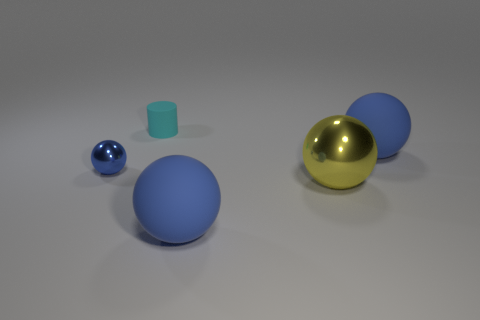How many blue balls must be subtracted to get 1 blue balls? 2 Subtract all brown cubes. How many blue balls are left? 3 Subtract all gray balls. Subtract all yellow blocks. How many balls are left? 4 Add 4 big yellow cylinders. How many objects exist? 9 Subtract all cylinders. How many objects are left? 4 Subtract all tiny purple blocks. Subtract all metallic objects. How many objects are left? 3 Add 2 cyan matte objects. How many cyan matte objects are left? 3 Add 3 big balls. How many big balls exist? 6 Subtract 1 cyan cylinders. How many objects are left? 4 